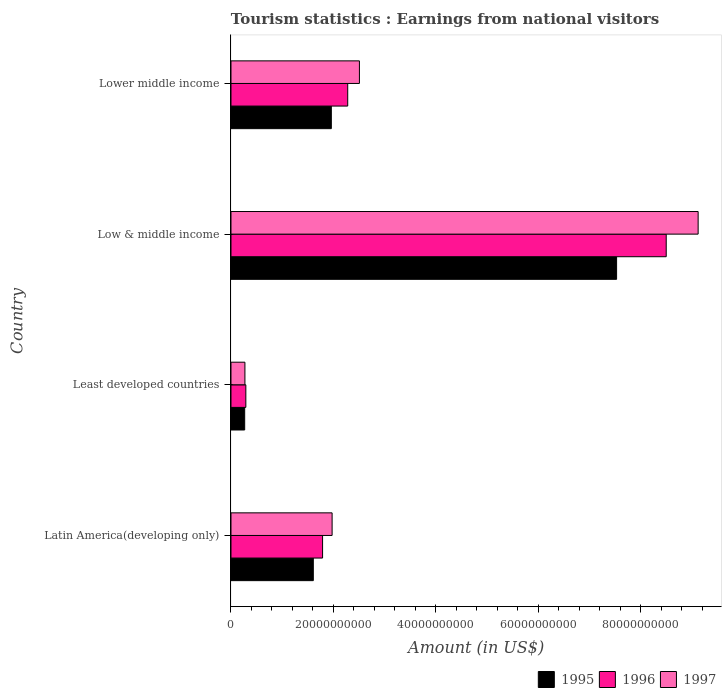How many different coloured bars are there?
Give a very brief answer. 3. How many groups of bars are there?
Ensure brevity in your answer.  4. Are the number of bars on each tick of the Y-axis equal?
Keep it short and to the point. Yes. What is the label of the 2nd group of bars from the top?
Ensure brevity in your answer.  Low & middle income. In how many cases, is the number of bars for a given country not equal to the number of legend labels?
Provide a succinct answer. 0. What is the earnings from national visitors in 1996 in Low & middle income?
Provide a succinct answer. 8.50e+1. Across all countries, what is the maximum earnings from national visitors in 1995?
Offer a terse response. 7.53e+1. Across all countries, what is the minimum earnings from national visitors in 1996?
Offer a very short reply. 2.90e+09. In which country was the earnings from national visitors in 1997 maximum?
Your answer should be compact. Low & middle income. In which country was the earnings from national visitors in 1995 minimum?
Provide a succinct answer. Least developed countries. What is the total earnings from national visitors in 1995 in the graph?
Your response must be concise. 1.14e+11. What is the difference between the earnings from national visitors in 1995 in Latin America(developing only) and that in Low & middle income?
Your answer should be compact. -5.92e+1. What is the difference between the earnings from national visitors in 1995 in Latin America(developing only) and the earnings from national visitors in 1997 in Least developed countries?
Your answer should be compact. 1.33e+1. What is the average earnings from national visitors in 1995 per country?
Give a very brief answer. 2.84e+1. What is the difference between the earnings from national visitors in 1995 and earnings from national visitors in 1997 in Low & middle income?
Offer a very short reply. -1.59e+1. What is the ratio of the earnings from national visitors in 1997 in Least developed countries to that in Lower middle income?
Offer a terse response. 0.11. Is the difference between the earnings from national visitors in 1995 in Least developed countries and Lower middle income greater than the difference between the earnings from national visitors in 1997 in Least developed countries and Lower middle income?
Your answer should be compact. Yes. What is the difference between the highest and the second highest earnings from national visitors in 1996?
Make the answer very short. 6.22e+1. What is the difference between the highest and the lowest earnings from national visitors in 1996?
Your answer should be very brief. 8.21e+1. In how many countries, is the earnings from national visitors in 1997 greater than the average earnings from national visitors in 1997 taken over all countries?
Ensure brevity in your answer.  1. Is the sum of the earnings from national visitors in 1995 in Latin America(developing only) and Least developed countries greater than the maximum earnings from national visitors in 1997 across all countries?
Offer a terse response. No. What does the 3rd bar from the top in Low & middle income represents?
Provide a succinct answer. 1995. Is it the case that in every country, the sum of the earnings from national visitors in 1996 and earnings from national visitors in 1995 is greater than the earnings from national visitors in 1997?
Give a very brief answer. Yes. Are all the bars in the graph horizontal?
Your answer should be compact. Yes. What is the difference between two consecutive major ticks on the X-axis?
Offer a terse response. 2.00e+1. Are the values on the major ticks of X-axis written in scientific E-notation?
Your answer should be compact. No. Does the graph contain any zero values?
Offer a very short reply. No. How many legend labels are there?
Give a very brief answer. 3. What is the title of the graph?
Your answer should be very brief. Tourism statistics : Earnings from national visitors. What is the label or title of the Y-axis?
Your response must be concise. Country. What is the Amount (in US$) of 1995 in Latin America(developing only)?
Make the answer very short. 1.61e+1. What is the Amount (in US$) of 1996 in Latin America(developing only)?
Provide a short and direct response. 1.79e+1. What is the Amount (in US$) in 1997 in Latin America(developing only)?
Offer a terse response. 1.97e+1. What is the Amount (in US$) of 1995 in Least developed countries?
Ensure brevity in your answer.  2.68e+09. What is the Amount (in US$) of 1996 in Least developed countries?
Provide a short and direct response. 2.90e+09. What is the Amount (in US$) in 1997 in Least developed countries?
Keep it short and to the point. 2.72e+09. What is the Amount (in US$) of 1995 in Low & middle income?
Give a very brief answer. 7.53e+1. What is the Amount (in US$) in 1996 in Low & middle income?
Your response must be concise. 8.50e+1. What is the Amount (in US$) in 1997 in Low & middle income?
Your response must be concise. 9.12e+1. What is the Amount (in US$) in 1995 in Lower middle income?
Give a very brief answer. 1.96e+1. What is the Amount (in US$) of 1996 in Lower middle income?
Keep it short and to the point. 2.28e+1. What is the Amount (in US$) of 1997 in Lower middle income?
Offer a very short reply. 2.51e+1. Across all countries, what is the maximum Amount (in US$) in 1995?
Ensure brevity in your answer.  7.53e+1. Across all countries, what is the maximum Amount (in US$) in 1996?
Your answer should be very brief. 8.50e+1. Across all countries, what is the maximum Amount (in US$) of 1997?
Provide a succinct answer. 9.12e+1. Across all countries, what is the minimum Amount (in US$) of 1995?
Your answer should be compact. 2.68e+09. Across all countries, what is the minimum Amount (in US$) in 1996?
Your answer should be very brief. 2.90e+09. Across all countries, what is the minimum Amount (in US$) in 1997?
Give a very brief answer. 2.72e+09. What is the total Amount (in US$) in 1995 in the graph?
Keep it short and to the point. 1.14e+11. What is the total Amount (in US$) of 1996 in the graph?
Your response must be concise. 1.29e+11. What is the total Amount (in US$) in 1997 in the graph?
Provide a succinct answer. 1.39e+11. What is the difference between the Amount (in US$) of 1995 in Latin America(developing only) and that in Least developed countries?
Give a very brief answer. 1.34e+1. What is the difference between the Amount (in US$) in 1996 in Latin America(developing only) and that in Least developed countries?
Provide a short and direct response. 1.50e+1. What is the difference between the Amount (in US$) of 1997 in Latin America(developing only) and that in Least developed countries?
Give a very brief answer. 1.70e+1. What is the difference between the Amount (in US$) of 1995 in Latin America(developing only) and that in Low & middle income?
Make the answer very short. -5.92e+1. What is the difference between the Amount (in US$) in 1996 in Latin America(developing only) and that in Low & middle income?
Make the answer very short. -6.71e+1. What is the difference between the Amount (in US$) in 1997 in Latin America(developing only) and that in Low & middle income?
Offer a very short reply. -7.14e+1. What is the difference between the Amount (in US$) in 1995 in Latin America(developing only) and that in Lower middle income?
Ensure brevity in your answer.  -3.52e+09. What is the difference between the Amount (in US$) of 1996 in Latin America(developing only) and that in Lower middle income?
Offer a very short reply. -4.91e+09. What is the difference between the Amount (in US$) of 1997 in Latin America(developing only) and that in Lower middle income?
Give a very brief answer. -5.33e+09. What is the difference between the Amount (in US$) in 1995 in Least developed countries and that in Low & middle income?
Give a very brief answer. -7.26e+1. What is the difference between the Amount (in US$) in 1996 in Least developed countries and that in Low & middle income?
Provide a succinct answer. -8.21e+1. What is the difference between the Amount (in US$) in 1997 in Least developed countries and that in Low & middle income?
Offer a terse response. -8.85e+1. What is the difference between the Amount (in US$) of 1995 in Least developed countries and that in Lower middle income?
Your answer should be very brief. -1.69e+1. What is the difference between the Amount (in US$) of 1996 in Least developed countries and that in Lower middle income?
Provide a succinct answer. -1.99e+1. What is the difference between the Amount (in US$) in 1997 in Least developed countries and that in Lower middle income?
Give a very brief answer. -2.23e+1. What is the difference between the Amount (in US$) of 1995 in Low & middle income and that in Lower middle income?
Give a very brief answer. 5.57e+1. What is the difference between the Amount (in US$) of 1996 in Low & middle income and that in Lower middle income?
Make the answer very short. 6.22e+1. What is the difference between the Amount (in US$) of 1997 in Low & middle income and that in Lower middle income?
Ensure brevity in your answer.  6.61e+1. What is the difference between the Amount (in US$) of 1995 in Latin America(developing only) and the Amount (in US$) of 1996 in Least developed countries?
Provide a short and direct response. 1.32e+1. What is the difference between the Amount (in US$) of 1995 in Latin America(developing only) and the Amount (in US$) of 1997 in Least developed countries?
Give a very brief answer. 1.33e+1. What is the difference between the Amount (in US$) of 1996 in Latin America(developing only) and the Amount (in US$) of 1997 in Least developed countries?
Your answer should be very brief. 1.52e+1. What is the difference between the Amount (in US$) in 1995 in Latin America(developing only) and the Amount (in US$) in 1996 in Low & middle income?
Provide a short and direct response. -6.89e+1. What is the difference between the Amount (in US$) of 1995 in Latin America(developing only) and the Amount (in US$) of 1997 in Low & middle income?
Your answer should be compact. -7.51e+1. What is the difference between the Amount (in US$) in 1996 in Latin America(developing only) and the Amount (in US$) in 1997 in Low & middle income?
Offer a very short reply. -7.33e+1. What is the difference between the Amount (in US$) in 1995 in Latin America(developing only) and the Amount (in US$) in 1996 in Lower middle income?
Offer a terse response. -6.71e+09. What is the difference between the Amount (in US$) of 1995 in Latin America(developing only) and the Amount (in US$) of 1997 in Lower middle income?
Make the answer very short. -9.00e+09. What is the difference between the Amount (in US$) of 1996 in Latin America(developing only) and the Amount (in US$) of 1997 in Lower middle income?
Give a very brief answer. -7.19e+09. What is the difference between the Amount (in US$) in 1995 in Least developed countries and the Amount (in US$) in 1996 in Low & middle income?
Your answer should be very brief. -8.23e+1. What is the difference between the Amount (in US$) of 1995 in Least developed countries and the Amount (in US$) of 1997 in Low & middle income?
Provide a succinct answer. -8.85e+1. What is the difference between the Amount (in US$) in 1996 in Least developed countries and the Amount (in US$) in 1997 in Low & middle income?
Offer a terse response. -8.83e+1. What is the difference between the Amount (in US$) of 1995 in Least developed countries and the Amount (in US$) of 1996 in Lower middle income?
Your answer should be very brief. -2.01e+1. What is the difference between the Amount (in US$) in 1995 in Least developed countries and the Amount (in US$) in 1997 in Lower middle income?
Provide a succinct answer. -2.24e+1. What is the difference between the Amount (in US$) in 1996 in Least developed countries and the Amount (in US$) in 1997 in Lower middle income?
Ensure brevity in your answer.  -2.22e+1. What is the difference between the Amount (in US$) in 1995 in Low & middle income and the Amount (in US$) in 1996 in Lower middle income?
Your answer should be compact. 5.25e+1. What is the difference between the Amount (in US$) of 1995 in Low & middle income and the Amount (in US$) of 1997 in Lower middle income?
Provide a short and direct response. 5.02e+1. What is the difference between the Amount (in US$) of 1996 in Low & middle income and the Amount (in US$) of 1997 in Lower middle income?
Provide a short and direct response. 5.99e+1. What is the average Amount (in US$) of 1995 per country?
Make the answer very short. 2.84e+1. What is the average Amount (in US$) in 1996 per country?
Provide a short and direct response. 3.21e+1. What is the average Amount (in US$) of 1997 per country?
Offer a terse response. 3.47e+1. What is the difference between the Amount (in US$) in 1995 and Amount (in US$) in 1996 in Latin America(developing only)?
Your response must be concise. -1.81e+09. What is the difference between the Amount (in US$) in 1995 and Amount (in US$) in 1997 in Latin America(developing only)?
Your response must be concise. -3.67e+09. What is the difference between the Amount (in US$) in 1996 and Amount (in US$) in 1997 in Latin America(developing only)?
Make the answer very short. -1.86e+09. What is the difference between the Amount (in US$) in 1995 and Amount (in US$) in 1996 in Least developed countries?
Provide a succinct answer. -2.27e+08. What is the difference between the Amount (in US$) in 1995 and Amount (in US$) in 1997 in Least developed countries?
Make the answer very short. -4.73e+07. What is the difference between the Amount (in US$) of 1996 and Amount (in US$) of 1997 in Least developed countries?
Give a very brief answer. 1.79e+08. What is the difference between the Amount (in US$) in 1995 and Amount (in US$) in 1996 in Low & middle income?
Ensure brevity in your answer.  -9.69e+09. What is the difference between the Amount (in US$) in 1995 and Amount (in US$) in 1997 in Low & middle income?
Provide a succinct answer. -1.59e+1. What is the difference between the Amount (in US$) of 1996 and Amount (in US$) of 1997 in Low & middle income?
Offer a very short reply. -6.23e+09. What is the difference between the Amount (in US$) of 1995 and Amount (in US$) of 1996 in Lower middle income?
Provide a succinct answer. -3.20e+09. What is the difference between the Amount (in US$) in 1995 and Amount (in US$) in 1997 in Lower middle income?
Provide a succinct answer. -5.48e+09. What is the difference between the Amount (in US$) of 1996 and Amount (in US$) of 1997 in Lower middle income?
Your answer should be compact. -2.28e+09. What is the ratio of the Amount (in US$) in 1995 in Latin America(developing only) to that in Least developed countries?
Make the answer very short. 6.01. What is the ratio of the Amount (in US$) in 1996 in Latin America(developing only) to that in Least developed countries?
Your answer should be very brief. 6.16. What is the ratio of the Amount (in US$) of 1997 in Latin America(developing only) to that in Least developed countries?
Provide a short and direct response. 7.25. What is the ratio of the Amount (in US$) of 1995 in Latin America(developing only) to that in Low & middle income?
Offer a very short reply. 0.21. What is the ratio of the Amount (in US$) in 1996 in Latin America(developing only) to that in Low & middle income?
Provide a short and direct response. 0.21. What is the ratio of the Amount (in US$) of 1997 in Latin America(developing only) to that in Low & middle income?
Your answer should be compact. 0.22. What is the ratio of the Amount (in US$) of 1995 in Latin America(developing only) to that in Lower middle income?
Give a very brief answer. 0.82. What is the ratio of the Amount (in US$) of 1996 in Latin America(developing only) to that in Lower middle income?
Offer a very short reply. 0.78. What is the ratio of the Amount (in US$) in 1997 in Latin America(developing only) to that in Lower middle income?
Keep it short and to the point. 0.79. What is the ratio of the Amount (in US$) in 1995 in Least developed countries to that in Low & middle income?
Your answer should be compact. 0.04. What is the ratio of the Amount (in US$) in 1996 in Least developed countries to that in Low & middle income?
Provide a short and direct response. 0.03. What is the ratio of the Amount (in US$) of 1997 in Least developed countries to that in Low & middle income?
Make the answer very short. 0.03. What is the ratio of the Amount (in US$) in 1995 in Least developed countries to that in Lower middle income?
Keep it short and to the point. 0.14. What is the ratio of the Amount (in US$) of 1996 in Least developed countries to that in Lower middle income?
Provide a succinct answer. 0.13. What is the ratio of the Amount (in US$) in 1997 in Least developed countries to that in Lower middle income?
Make the answer very short. 0.11. What is the ratio of the Amount (in US$) of 1995 in Low & middle income to that in Lower middle income?
Make the answer very short. 3.84. What is the ratio of the Amount (in US$) in 1996 in Low & middle income to that in Lower middle income?
Keep it short and to the point. 3.73. What is the ratio of the Amount (in US$) in 1997 in Low & middle income to that in Lower middle income?
Offer a very short reply. 3.64. What is the difference between the highest and the second highest Amount (in US$) of 1995?
Ensure brevity in your answer.  5.57e+1. What is the difference between the highest and the second highest Amount (in US$) of 1996?
Offer a very short reply. 6.22e+1. What is the difference between the highest and the second highest Amount (in US$) in 1997?
Offer a very short reply. 6.61e+1. What is the difference between the highest and the lowest Amount (in US$) of 1995?
Offer a very short reply. 7.26e+1. What is the difference between the highest and the lowest Amount (in US$) of 1996?
Give a very brief answer. 8.21e+1. What is the difference between the highest and the lowest Amount (in US$) in 1997?
Ensure brevity in your answer.  8.85e+1. 